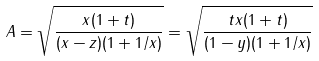<formula> <loc_0><loc_0><loc_500><loc_500>A = \sqrt { \frac { x ( 1 + t ) } { ( x - z ) ( 1 + 1 / x ) } } = \sqrt { \frac { t x ( 1 + t ) } { ( 1 - y ) ( 1 + 1 / x ) } }</formula> 